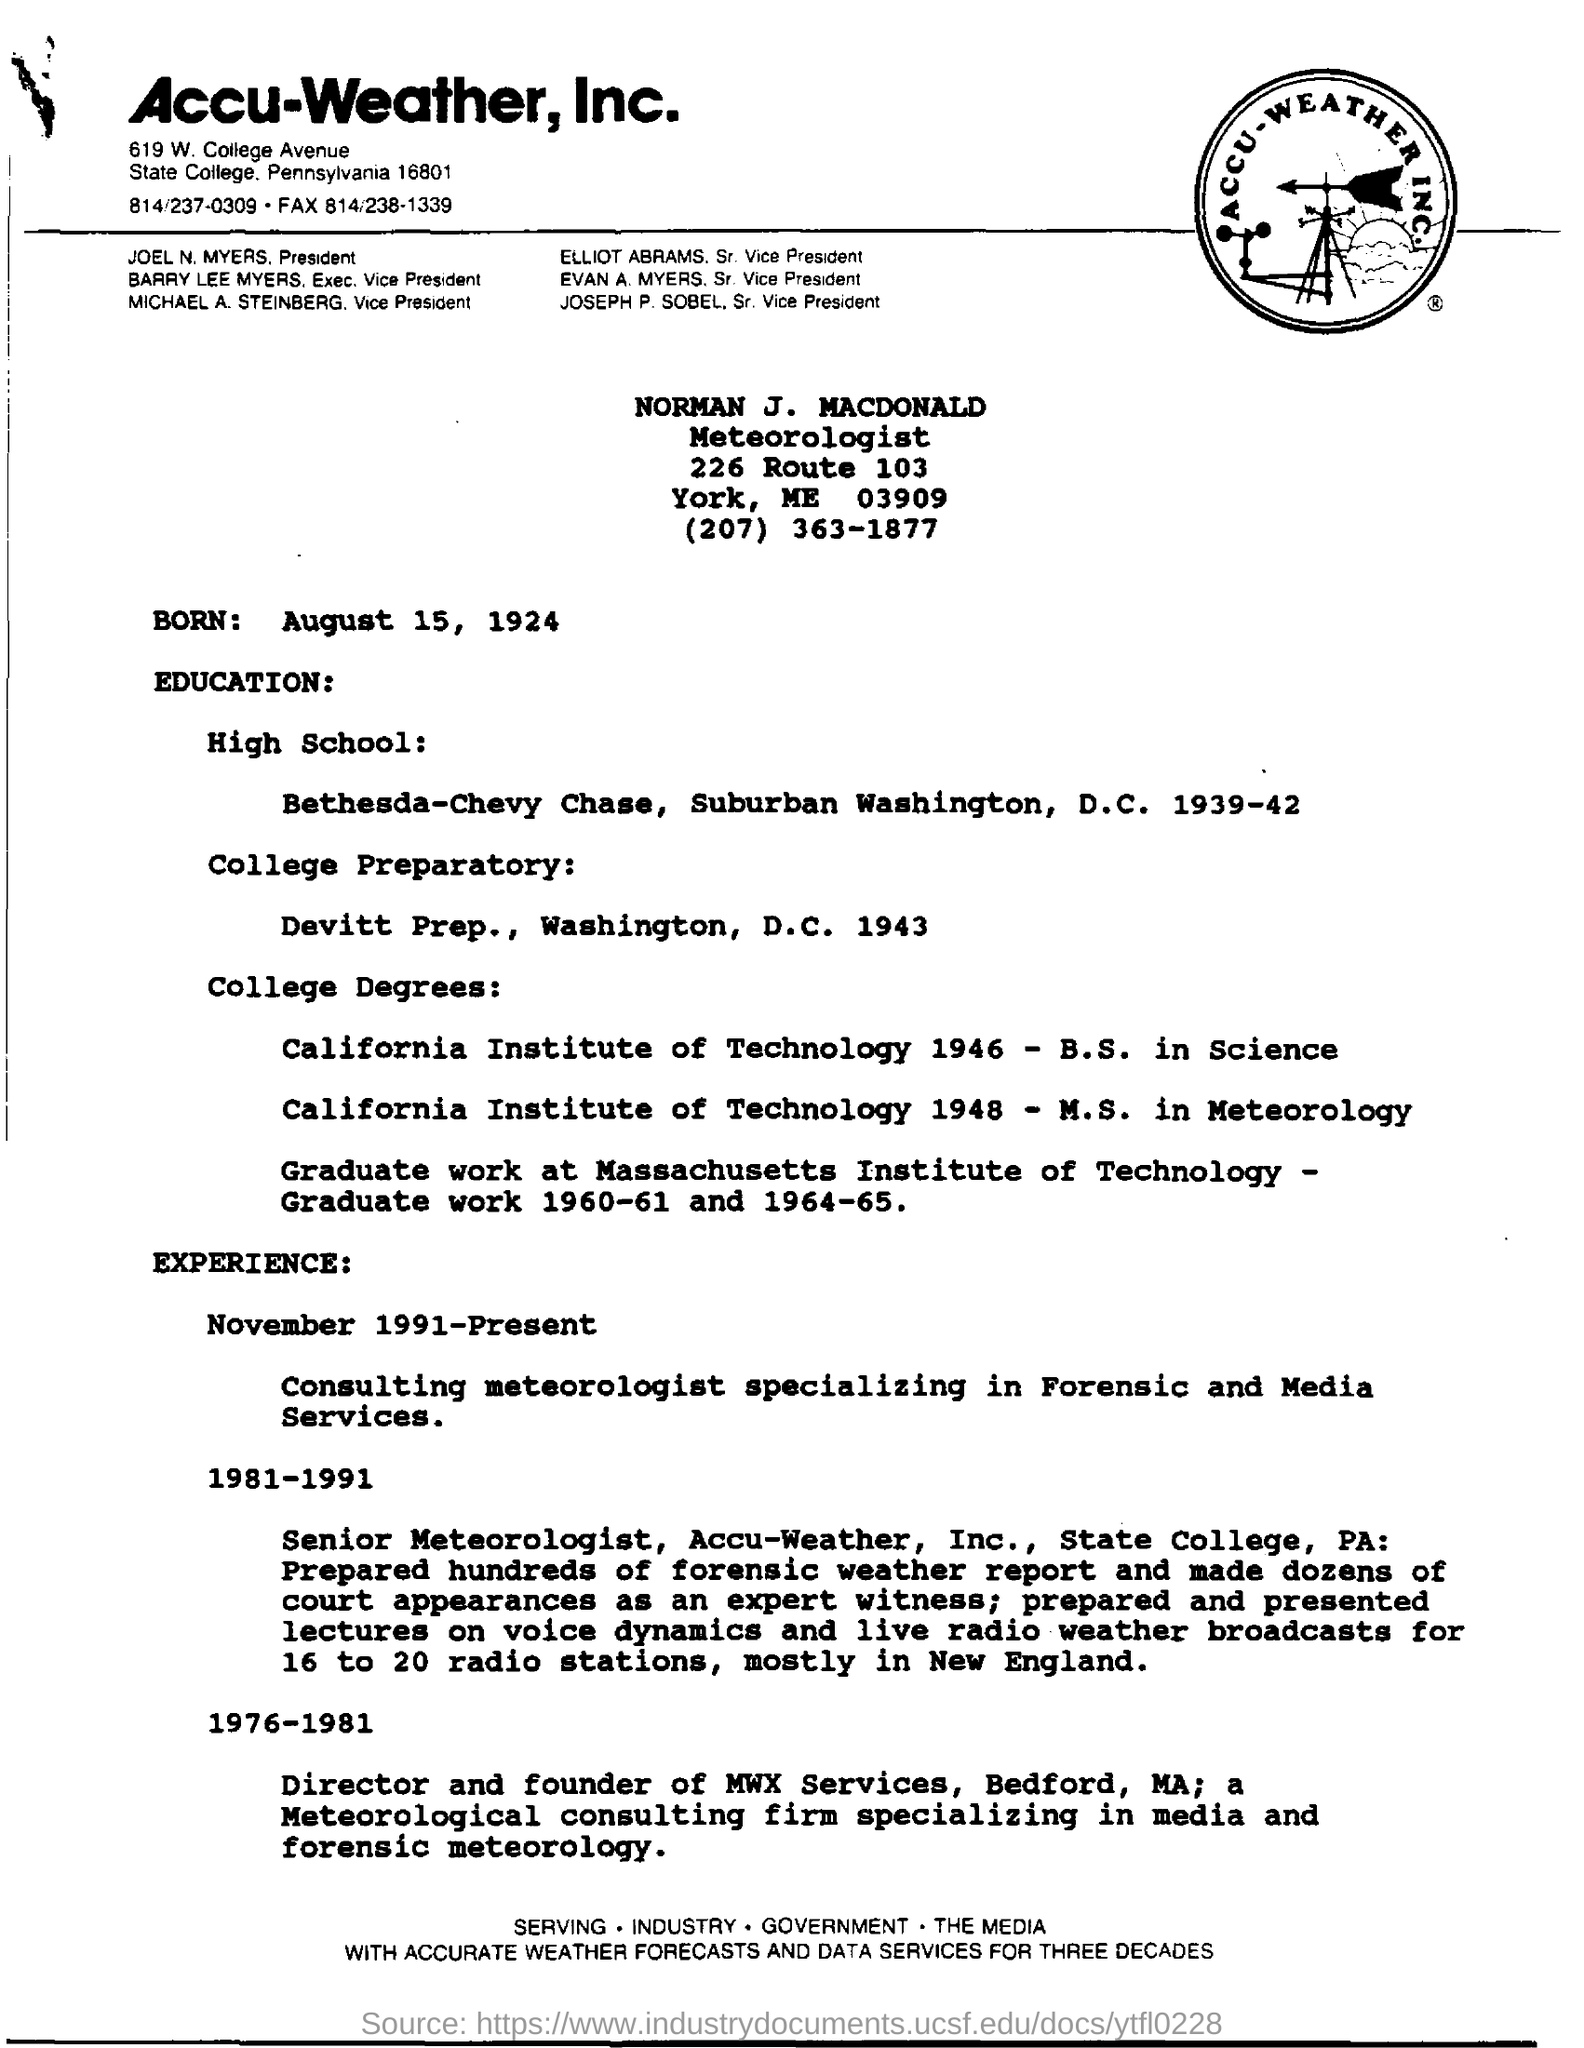Which company is mentioned in the letterhead?
Provide a succinct answer. Accu-Weather, Inc. What is the date of birth of Norman J. Macdonald?
Offer a terse response. August 15, 1924. What is the designation of Norman J. Macdonald?
Provide a short and direct response. Meteorologist. What is the date of birth?
Give a very brief answer. August 15, 1924. 